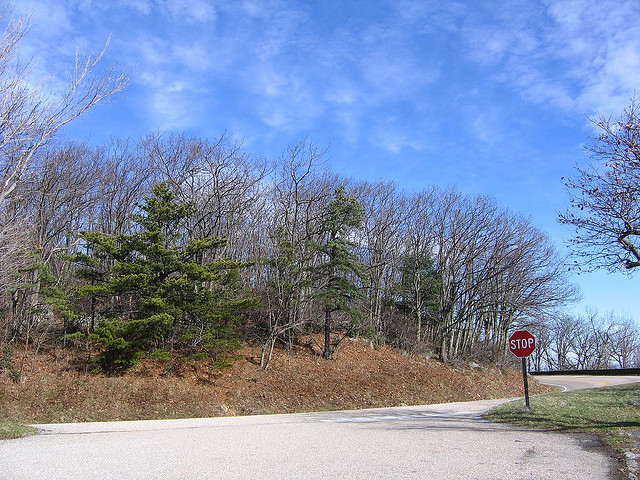What kind of weather is this? The weather is sunny with few clouds, suggesting a clear and pleasant day. 